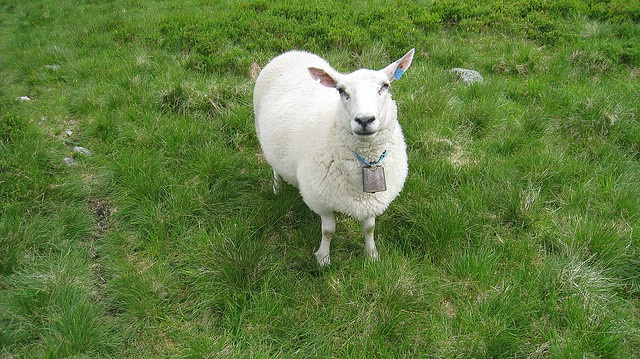Describe the objects in this image and their specific colors. I can see a sheep in darkgreen, lightgray, darkgray, and gray tones in this image. 